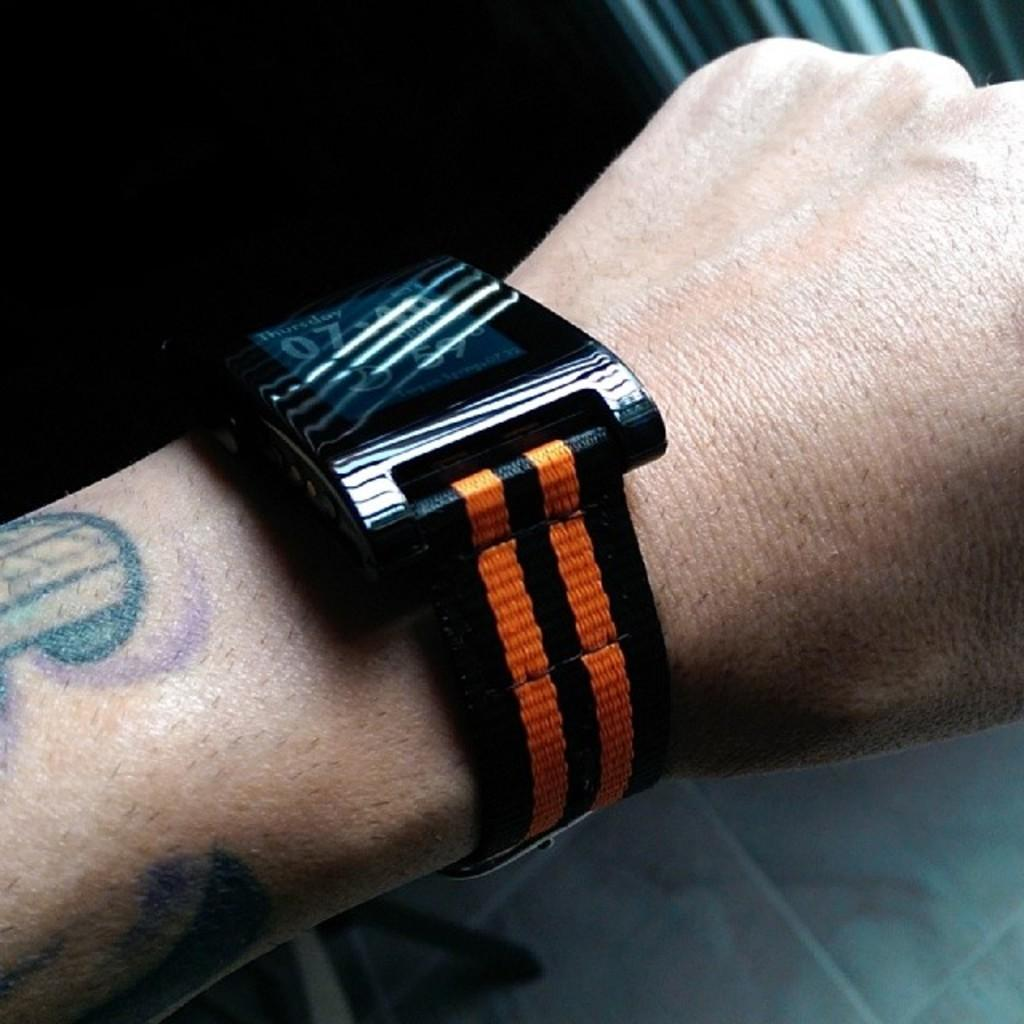<image>
Relay a brief, clear account of the picture shown. A watch display has Thursday on the screen. 